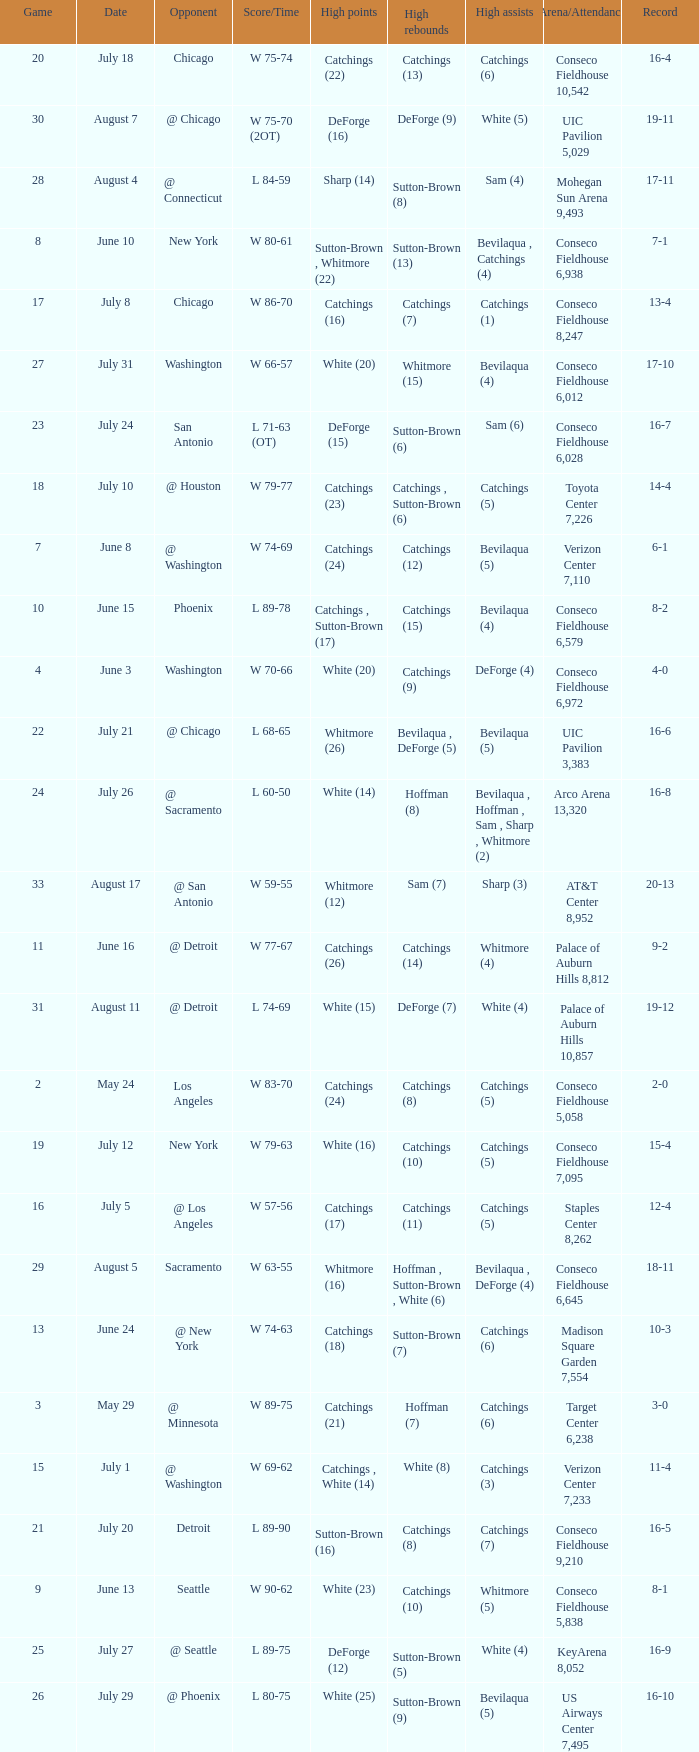Name the date where score time is w 74-63 June 24. 